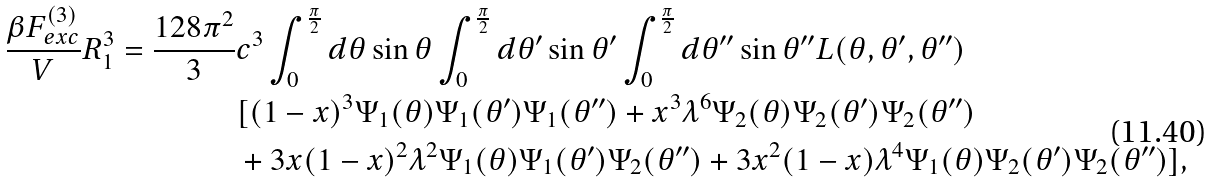<formula> <loc_0><loc_0><loc_500><loc_500>\frac { \beta F _ { e x c } ^ { ( 3 ) } } { V } R _ { 1 } ^ { 3 } = \frac { 1 2 8 \pi ^ { 2 } } { 3 } & c ^ { 3 } \int _ { 0 } ^ { \frac { \pi } { 2 } } d \theta \sin \theta \int _ { 0 } ^ { \frac { \pi } { 2 } } d \theta ^ { \prime } \sin \theta ^ { \prime } \int _ { 0 } ^ { \frac { \pi } { 2 } } d \theta ^ { \prime \prime } \sin \theta ^ { \prime \prime } L ( \theta , \theta ^ { \prime } , \theta ^ { \prime \prime } ) \\ & [ ( 1 - x ) ^ { 3 } \Psi _ { 1 } ( \theta ) \Psi _ { 1 } ( \theta ^ { \prime } ) \Psi _ { 1 } ( \theta ^ { \prime \prime } ) + x ^ { 3 } \lambda ^ { 6 } \Psi _ { 2 } ( \theta ) \Psi _ { 2 } ( \theta ^ { \prime } ) \Psi _ { 2 } ( \theta ^ { \prime \prime } ) \\ & + 3 x ( 1 - x ) ^ { 2 } \lambda ^ { 2 } \Psi _ { 1 } ( \theta ) \Psi _ { 1 } ( \theta ^ { \prime } ) \Psi _ { 2 } ( \theta ^ { \prime \prime } ) + 3 x ^ { 2 } ( 1 - x ) \lambda ^ { 4 } \Psi _ { 1 } ( \theta ) \Psi _ { 2 } ( \theta ^ { \prime } ) \Psi _ { 2 } ( \theta ^ { \prime \prime } ) ] ,</formula> 